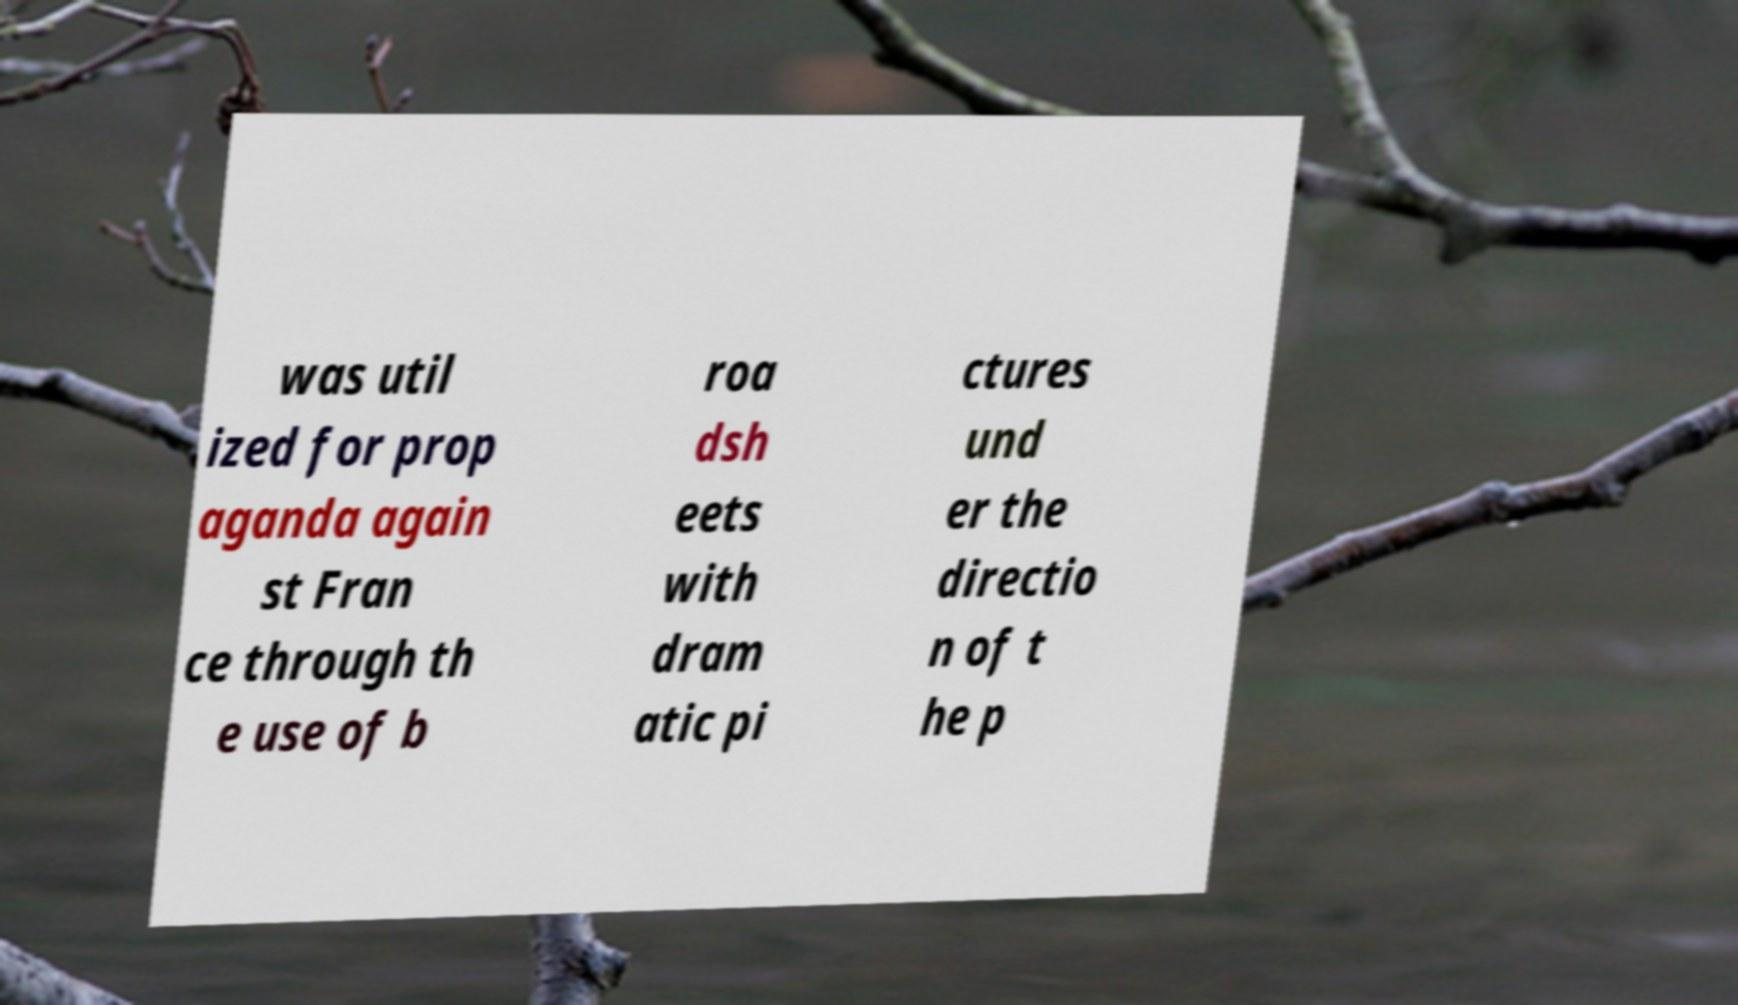For documentation purposes, I need the text within this image transcribed. Could you provide that? was util ized for prop aganda again st Fran ce through th e use of b roa dsh eets with dram atic pi ctures und er the directio n of t he p 